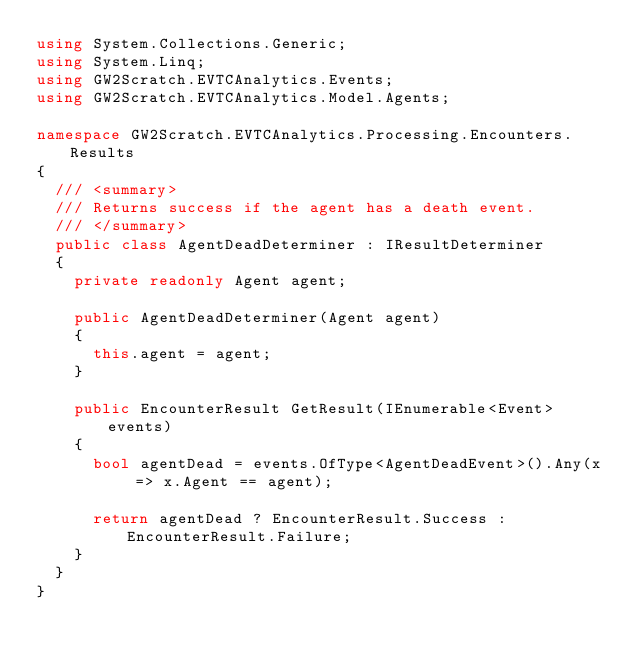Convert code to text. <code><loc_0><loc_0><loc_500><loc_500><_C#_>using System.Collections.Generic;
using System.Linq;
using GW2Scratch.EVTCAnalytics.Events;
using GW2Scratch.EVTCAnalytics.Model.Agents;

namespace GW2Scratch.EVTCAnalytics.Processing.Encounters.Results
{
	/// <summary>
	/// Returns success if the agent has a death event.
	/// </summary>
	public class AgentDeadDeterminer : IResultDeterminer
	{
		private readonly Agent agent;

		public AgentDeadDeterminer(Agent agent)
		{
			this.agent = agent;
		}

		public EncounterResult GetResult(IEnumerable<Event> events)
		{
			bool agentDead = events.OfType<AgentDeadEvent>().Any(x => x.Agent == agent);

			return agentDead ? EncounterResult.Success : EncounterResult.Failure;
		}
	}
}
</code> 